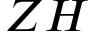<formula> <loc_0><loc_0><loc_500><loc_500>Z H</formula> 